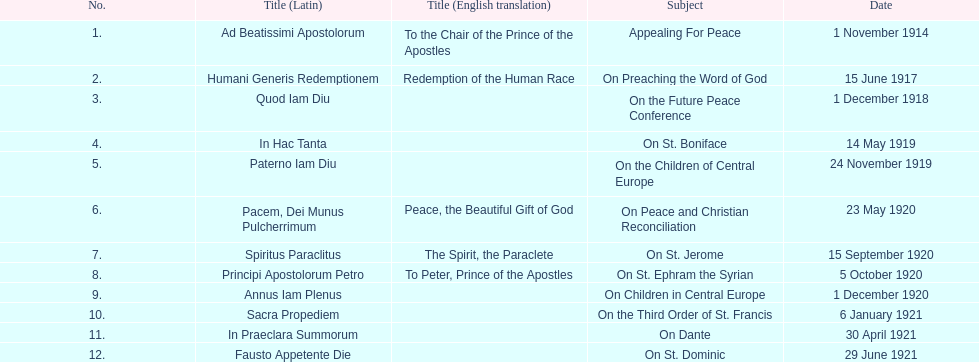After 1 december 1918 when was the next encyclical? 14 May 1919. 